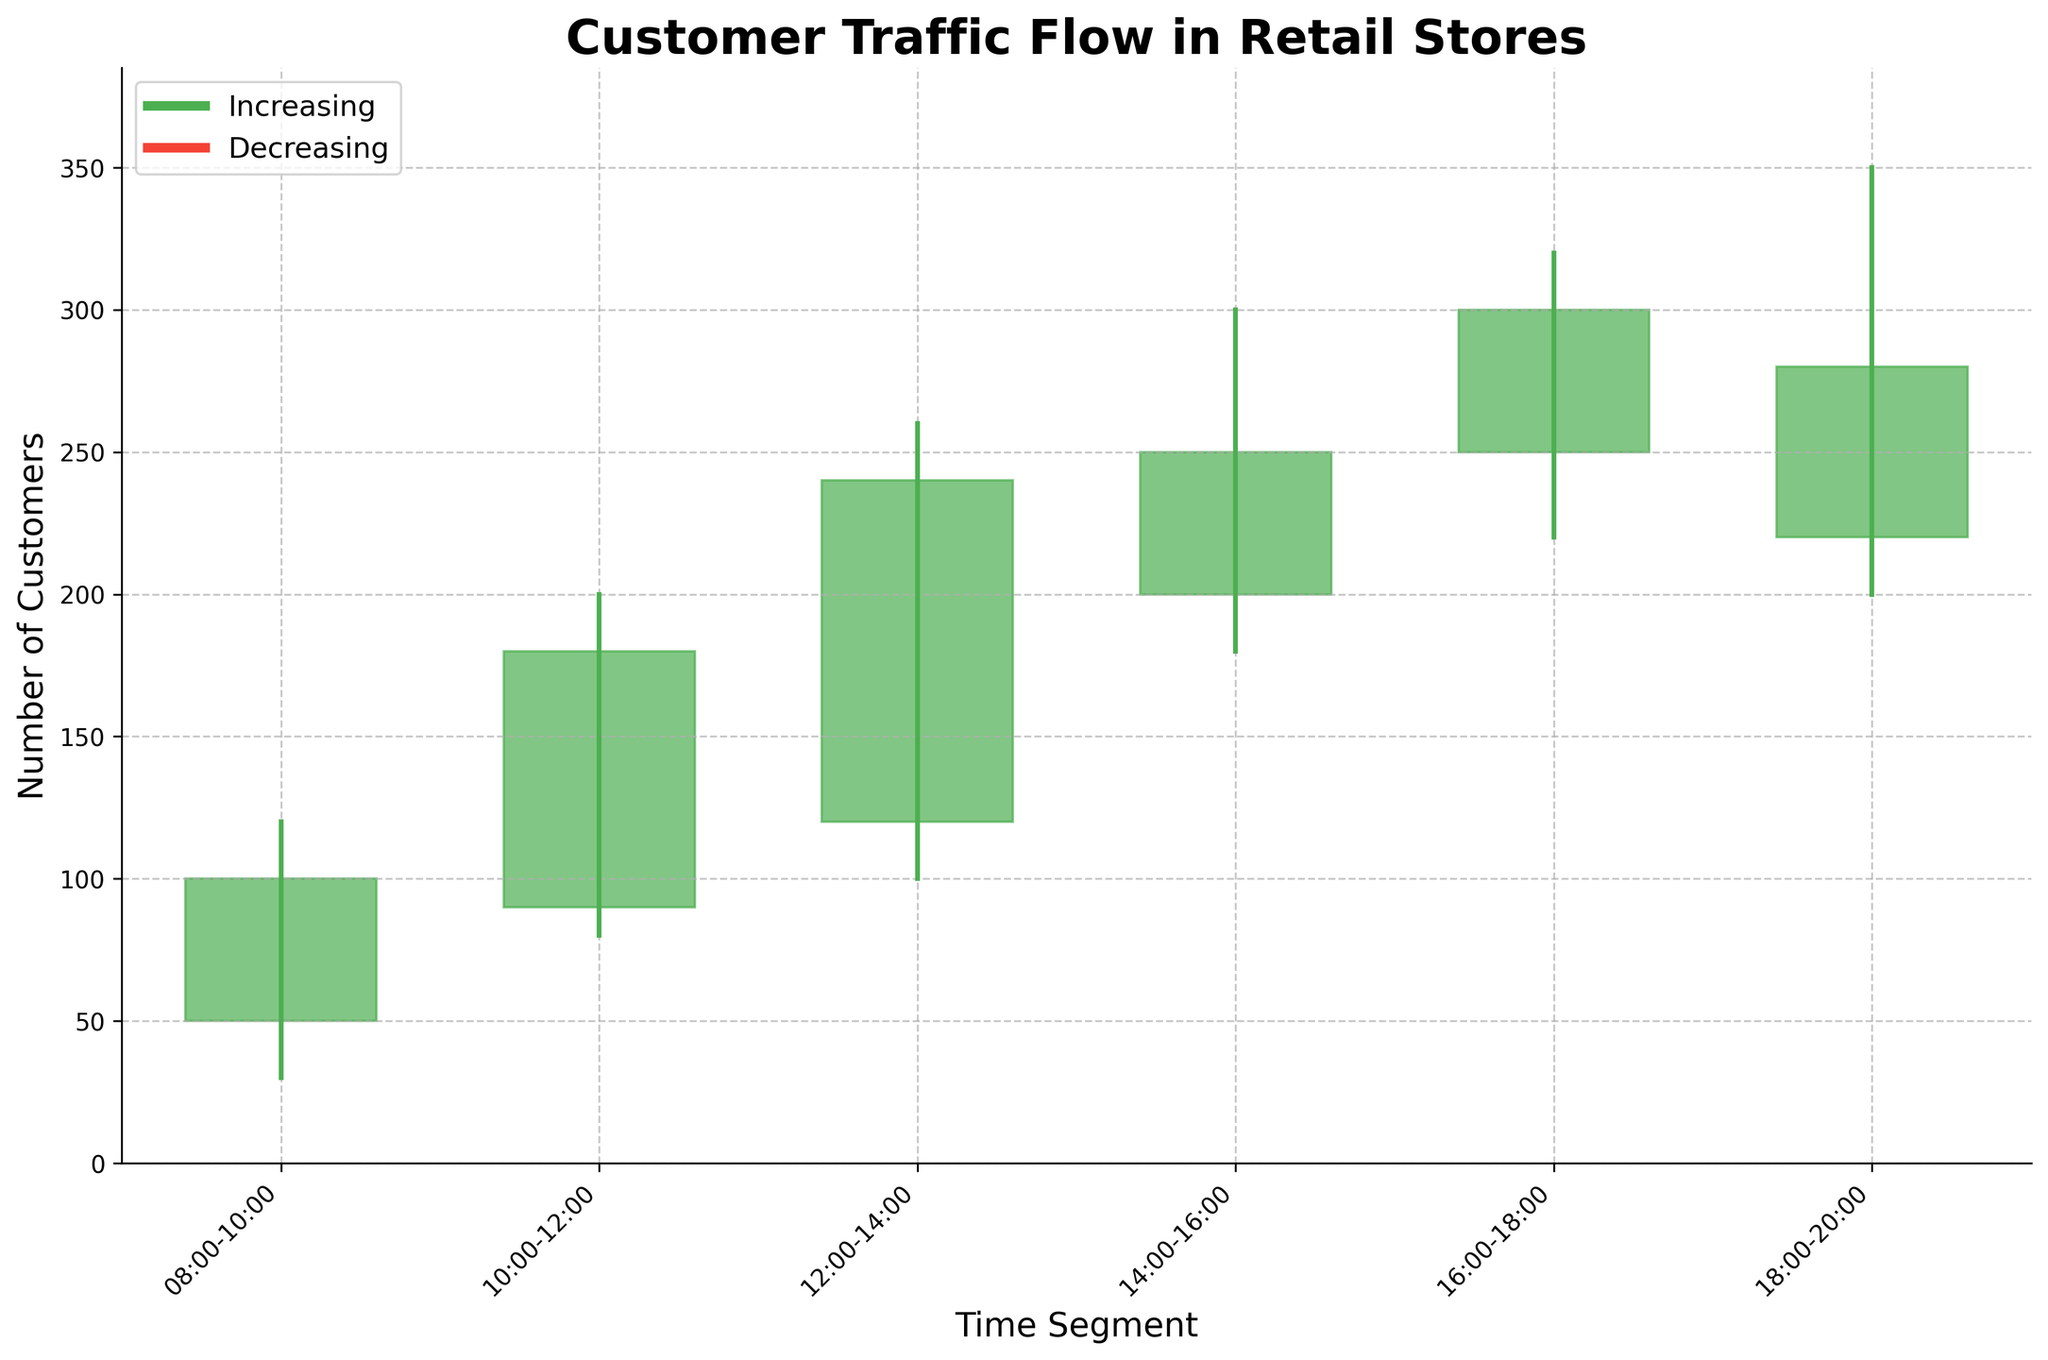What is the title of the plot? The title of the plot is typically located at the top of the figure. Here, the title reads "Customer Traffic Flow in Retail Stores."
Answer: Customer Traffic Flow in Retail Stores What does the y-axis represent? The y-axis generally represents the measure or quantity being plotted in the figure. In this case, it represents the "Number of Customers."
Answer: Number of Customers How is the time segmented in this plot? The x-axis labels define the time segments. They are: 08:00-10:00, 10:00-12:00, 12:00-14:00, 14:00-16:00, 16:00-18:00, and 18:00-20:00.
Answer: 08:00-10:00, 10:00-12:00, 12:00-14:00, 14:00-16:00, 16:00-18:00, 18:00-20:00 Which time segment had the highest customer traffic peak? To find the highest peak, look at the highest values on the candlesticks. The peak value "High" for each segment is plotted as the top of the vertical line. The time segment 18:00-20:00 has the highest peak at 350.
Answer: 18:00-20:00 During which time segment did customer traffic decrease? A decrease is represented by a red candlestick. We observe red candlesticks to see where "Open" is higher than "Close." The time segment 18:00-20:00 shows a decrease from 220 to 280 customers.
Answer: 18:00-20:00 What was the lowest customer traffic during the 12:00-14:00 segment? The lowest customer traffic is indicated by the "Low" value at the bottom of the vertical line in the 12:00-14:00 candlestick. It is 100 customers.
Answer: 100 What average number of customers was recorded at opening times across all segments? Sum all "Open" values and divide by the number of segments. The opens are: 50, 90, 120, 200, 250, and 220. Adding them up: 50+90+120+200+250+220 = 930. There are 6 segments, so the average is 930/6.
Answer: 155 Which time segment experienced the most significant increase in customer traffic? To find the most significant increase, look at the height difference where "Close" is higher than "Open." This is between 12:00-14:00, where it increased from 120 to 240 customers.
Answer: 12:00-14:00 What was the customer traffic range during the 16:00-18:00 segment? The range is calculated as the difference between the "High" and "Low" values. For 16:00-18:00, it is 320 (High) - 220 (Low) = 100.
Answer: 100 Which time segment had the smallest difference between its "High" and "Low" values? Compare the difference between the "High" and "Low" values for each segment. The smallest difference is for 10:00-12:00 with a range of 200 (High) - 80 (Low) = 120.
Answer: 10:00-12:00 